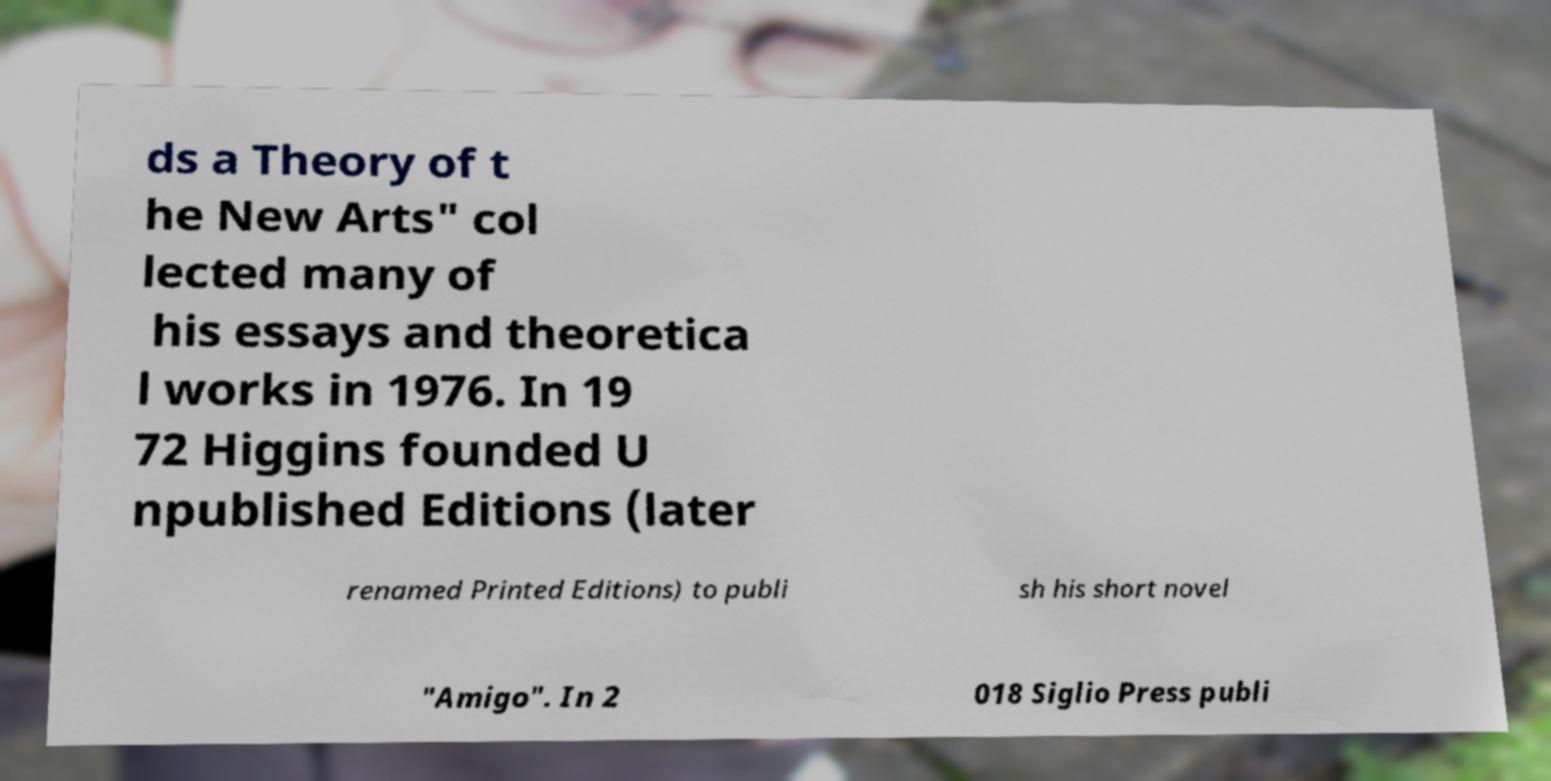Could you assist in decoding the text presented in this image and type it out clearly? ds a Theory of t he New Arts" col lected many of his essays and theoretica l works in 1976. In 19 72 Higgins founded U npublished Editions (later renamed Printed Editions) to publi sh his short novel "Amigo". In 2 018 Siglio Press publi 